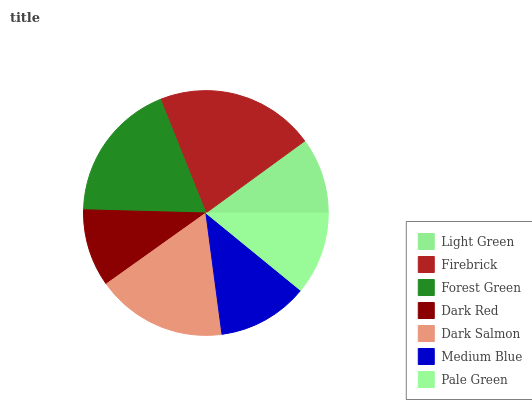Is Light Green the minimum?
Answer yes or no. Yes. Is Firebrick the maximum?
Answer yes or no. Yes. Is Forest Green the minimum?
Answer yes or no. No. Is Forest Green the maximum?
Answer yes or no. No. Is Firebrick greater than Forest Green?
Answer yes or no. Yes. Is Forest Green less than Firebrick?
Answer yes or no. Yes. Is Forest Green greater than Firebrick?
Answer yes or no. No. Is Firebrick less than Forest Green?
Answer yes or no. No. Is Medium Blue the high median?
Answer yes or no. Yes. Is Medium Blue the low median?
Answer yes or no. Yes. Is Dark Red the high median?
Answer yes or no. No. Is Dark Red the low median?
Answer yes or no. No. 